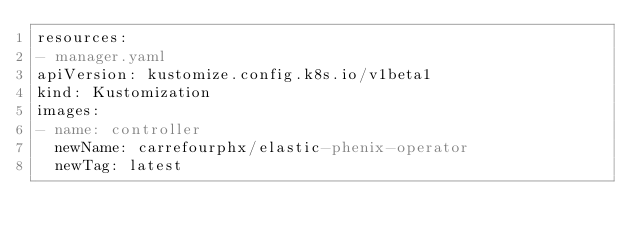<code> <loc_0><loc_0><loc_500><loc_500><_YAML_>resources:
- manager.yaml
apiVersion: kustomize.config.k8s.io/v1beta1
kind: Kustomization
images:
- name: controller
  newName: carrefourphx/elastic-phenix-operator
  newTag: latest
</code> 